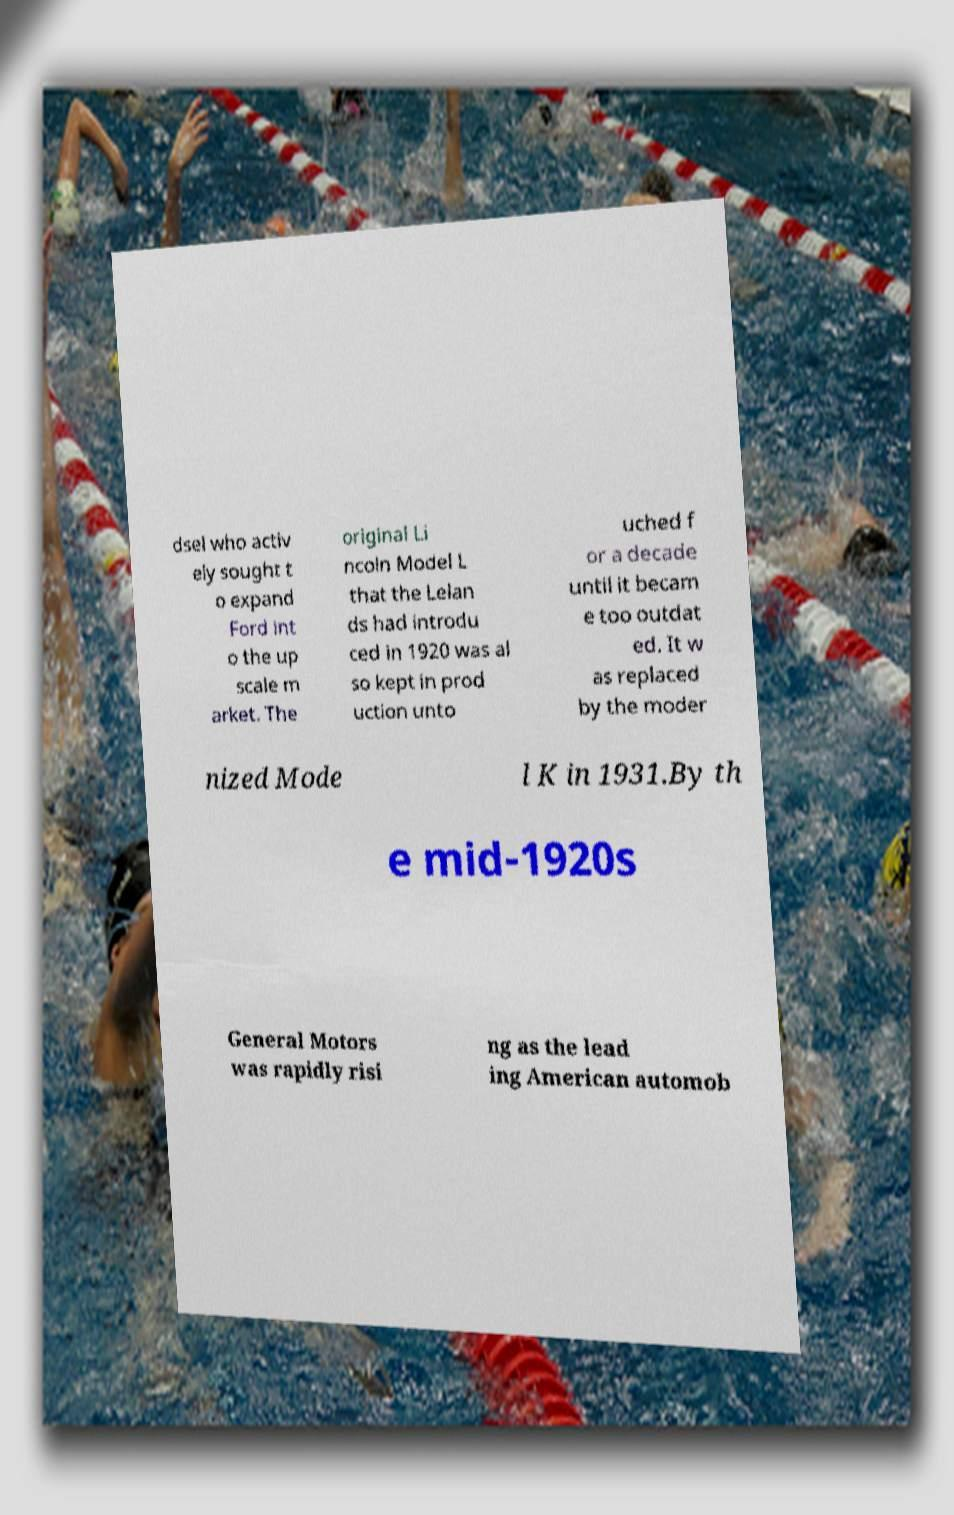For documentation purposes, I need the text within this image transcribed. Could you provide that? dsel who activ ely sought t o expand Ford int o the up scale m arket. The original Li ncoln Model L that the Lelan ds had introdu ced in 1920 was al so kept in prod uction unto uched f or a decade until it becam e too outdat ed. It w as replaced by the moder nized Mode l K in 1931.By th e mid-1920s General Motors was rapidly risi ng as the lead ing American automob 